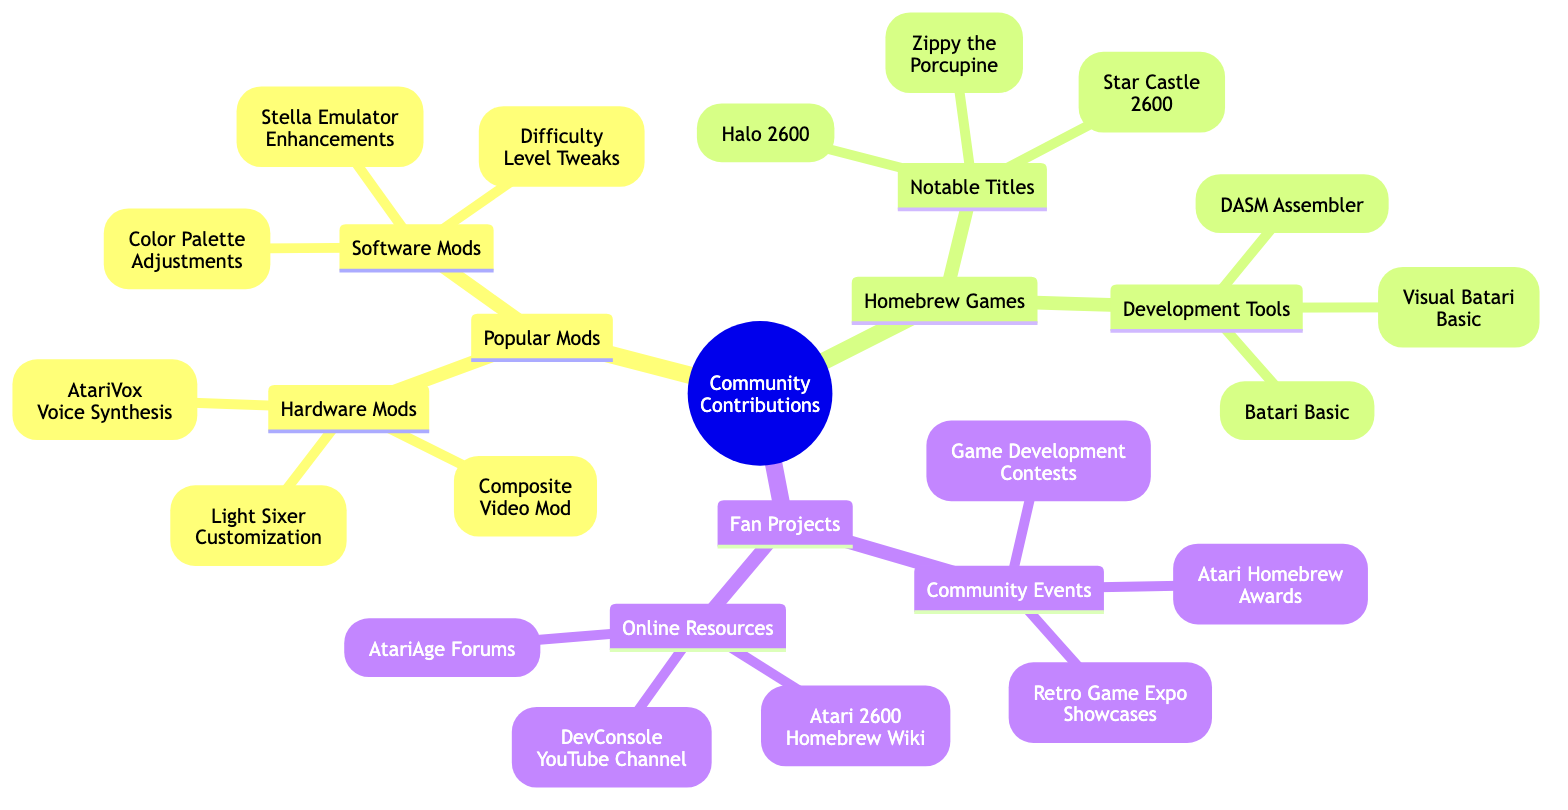What are the two main categories under Popular Mods? The diagram shows two subcategories under Popular Mods: Hardware Mods and Software Mods, indicating the different types of modifications that community members contribute.
Answer: Hardware Mods, Software Mods How many notable titles are listed under Homebrew Games? Under the Homebrew Games section, there are three specific titles mentioned: Halo 2600, Zippy the Porcupine, and Star Castle 2600. This is a straightforward count of the items listed.
Answer: 3 What is one development tool found in the Homebrew Games section? The Homebrew Games section lists Development Tools, including Batari Basic, DASM Assembler, and Visual Batari Basic. Any of these can be provided as an answer.
Answer: Batari Basic Which section contains the Atari Homebrew Awards? The Atari Homebrew Awards are listed under Fan Projects, specifically within the Community Events subsection, indicating the activities that engage the community in creative ways.
Answer: Fan Projects How are Online Resources related to Fan Projects? Online Resources is a subsection under Fan Projects, which illustrates that these resources are meant to support fan activities and projects. This shows the connection between available resources and community engagement.
Answer: Online Resources What is a common theme among the community events listed? The Community Events section includes activities designed to celebrate and promote homebrew and fan projects, showing a common theme of engagement and recognition within the community.
Answer: Engagement How many types of Mods are detailed in the diagram? The diagram categorizes mods into two types: Hardware Mods and Software Mods, clearly defining the types of modifications available for Atari 2600 games.
Answer: 2 What type of mod is the AtariVox Voice Synthesis Mod? The AtariVox Voice Synthesis Mod is categorized under Hardware Mods, indicating it is a physical modification to the console rather than a software change.
Answer: Hardware Mods Which fan project resource is focused on game development contests? The Game Development Contests are specifically listed under Community Events within the Fan Projects category, which highlights activities that encourage game development among enthusiasts.
Answer: Community Events 